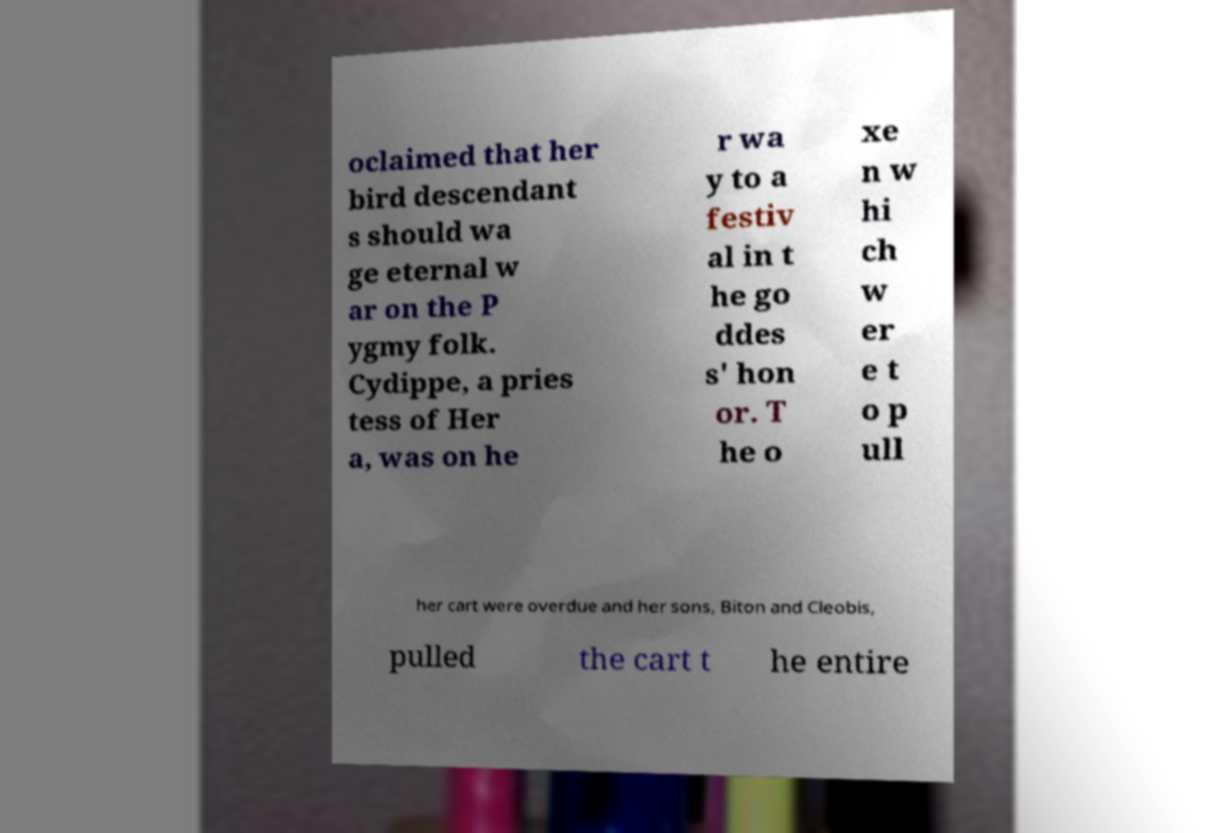Can you accurately transcribe the text from the provided image for me? oclaimed that her bird descendant s should wa ge eternal w ar on the P ygmy folk. Cydippe, a pries tess of Her a, was on he r wa y to a festiv al in t he go ddes s' hon or. T he o xe n w hi ch w er e t o p ull her cart were overdue and her sons, Biton and Cleobis, pulled the cart t he entire 